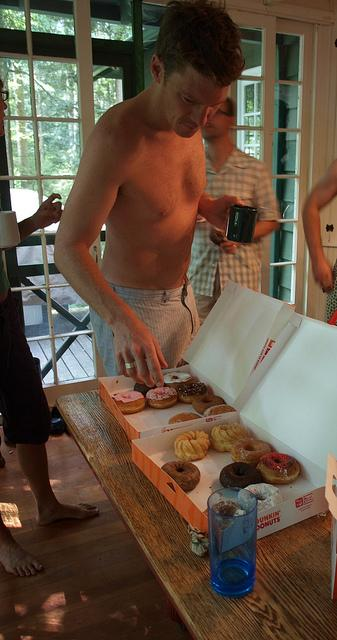What color is the icing on the top of the donuts underneath of the man's hand who is looking to eat? pink 